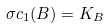Convert formula to latex. <formula><loc_0><loc_0><loc_500><loc_500>\sigma c _ { 1 } ( B ) = K _ { B }</formula> 